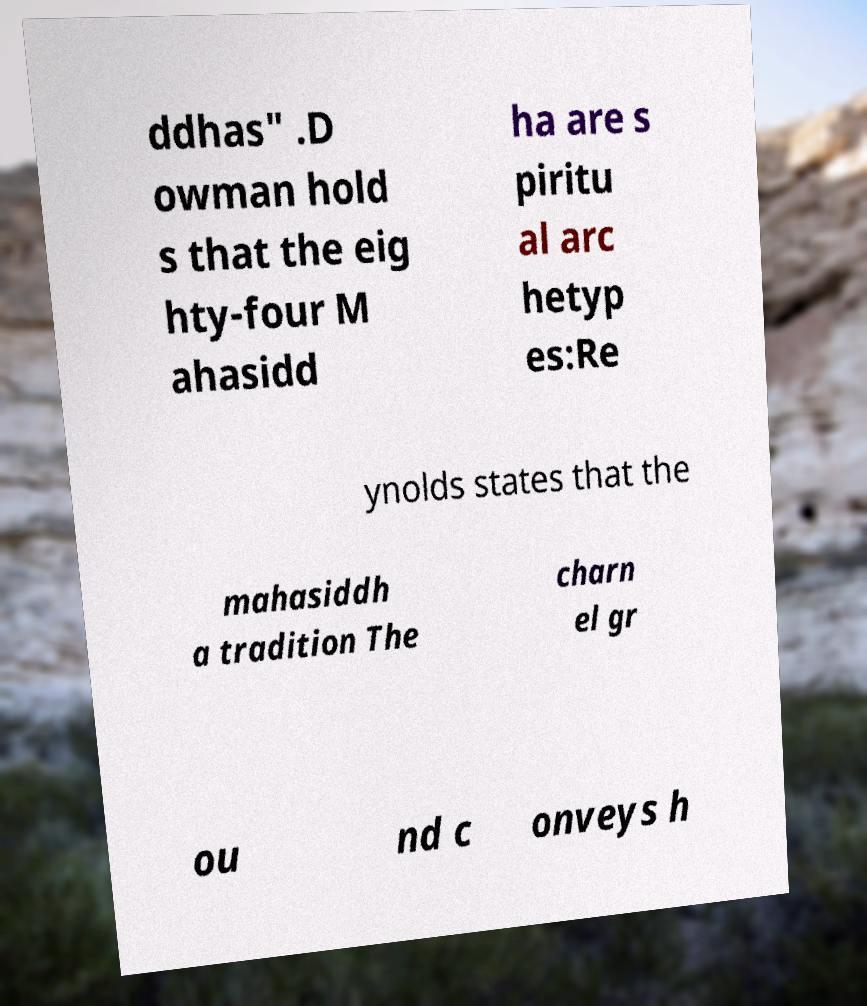What messages or text are displayed in this image? I need them in a readable, typed format. ddhas" .D owman hold s that the eig hty-four M ahasidd ha are s piritu al arc hetyp es:Re ynolds states that the mahasiddh a tradition The charn el gr ou nd c onveys h 